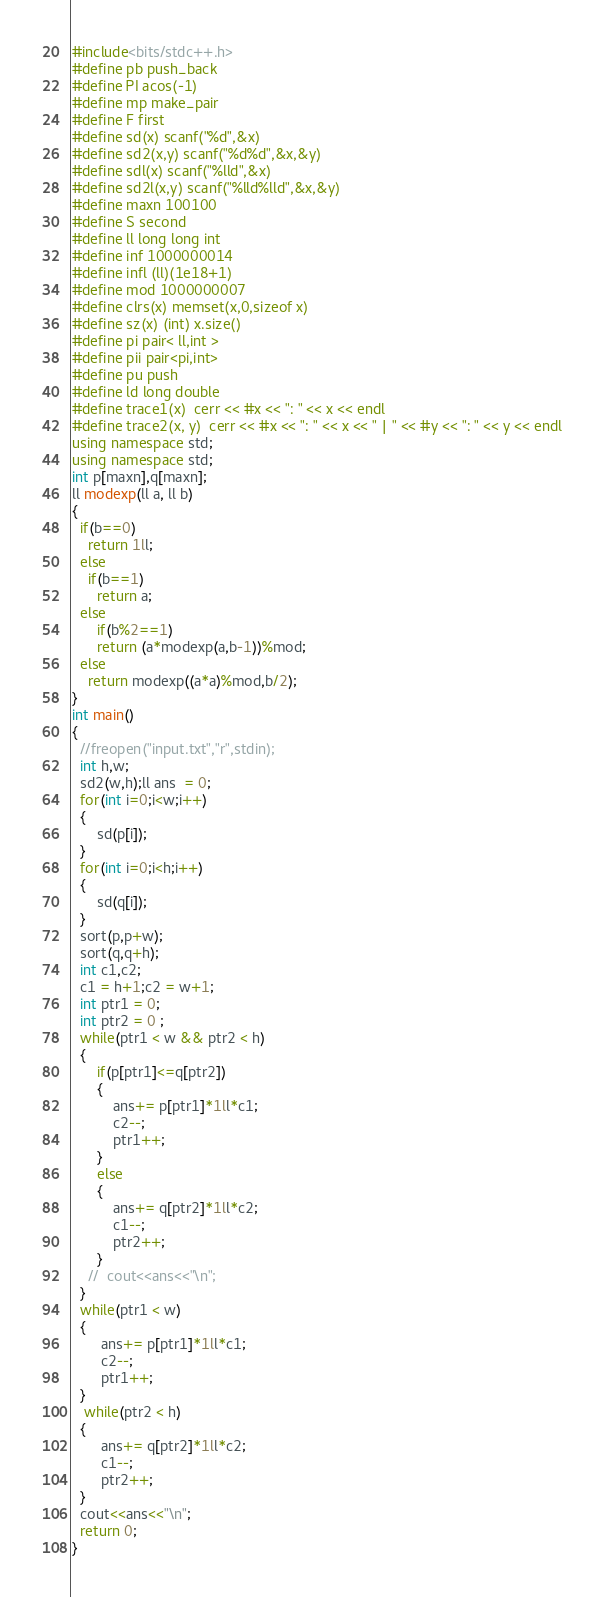Convert code to text. <code><loc_0><loc_0><loc_500><loc_500><_C++_>#include<bits/stdc++.h>
#define pb push_back
#define PI acos(-1)
#define mp make_pair
#define F first
#define sd(x) scanf("%d",&x)
#define sd2(x,y) scanf("%d%d",&x,&y)
#define sdl(x) scanf("%lld",&x)
#define sd2l(x,y) scanf("%lld%lld",&x,&y)
#define maxn 100100
#define S second
#define ll long long int
#define inf 1000000014
#define infl (ll)(1e18+1)
#define mod 1000000007
#define clrs(x) memset(x,0,sizeof x)
#define sz(x) (int) x.size()
#define pi pair< ll,int >
#define pii pair<pi,int>
#define pu push
#define ld long double
#define trace1(x)  cerr << #x << ": " << x << endl
#define trace2(x, y)  cerr << #x << ": " << x << " | " << #y << ": " << y << endl
using namespace std;
using namespace std;
int p[maxn],q[maxn];
ll modexp(ll a, ll b)
{
  if(b==0)
    return 1ll;
  else
    if(b==1)
      return a;
  else
      if(b%2==1)
      return (a*modexp(a,b-1))%mod;
  else
    return modexp((a*a)%mod,b/2);
}
int main()
{
  //freopen("input.txt","r",stdin);
  int h,w;
  sd2(w,h);ll ans  = 0;
  for(int i=0;i<w;i++)
  {
      sd(p[i]);
  }
  for(int i=0;i<h;i++)
  {
      sd(q[i]); 
  }
  sort(p,p+w);
  sort(q,q+h);
  int c1,c2;
  c1 = h+1;c2 = w+1; 
  int ptr1 = 0;
  int ptr2 = 0 ;
  while(ptr1 < w && ptr2 < h)
  {
      if(p[ptr1]<=q[ptr2])
      {
          ans+= p[ptr1]*1ll*c1;
          c2--;
          ptr1++;
      }
      else
      {
          ans+= q[ptr2]*1ll*c2;
          c1--;
          ptr2++;
      }
    //  cout<<ans<<"\n";
  }
  while(ptr1 < w)
  {
       ans+= p[ptr1]*1ll*c1;
       c2--;
       ptr1++;
  }
   while(ptr2 < h)
  {
       ans+= q[ptr2]*1ll*c2;
       c1--;
       ptr2++;
  }
  cout<<ans<<"\n";
  return 0;
}
</code> 